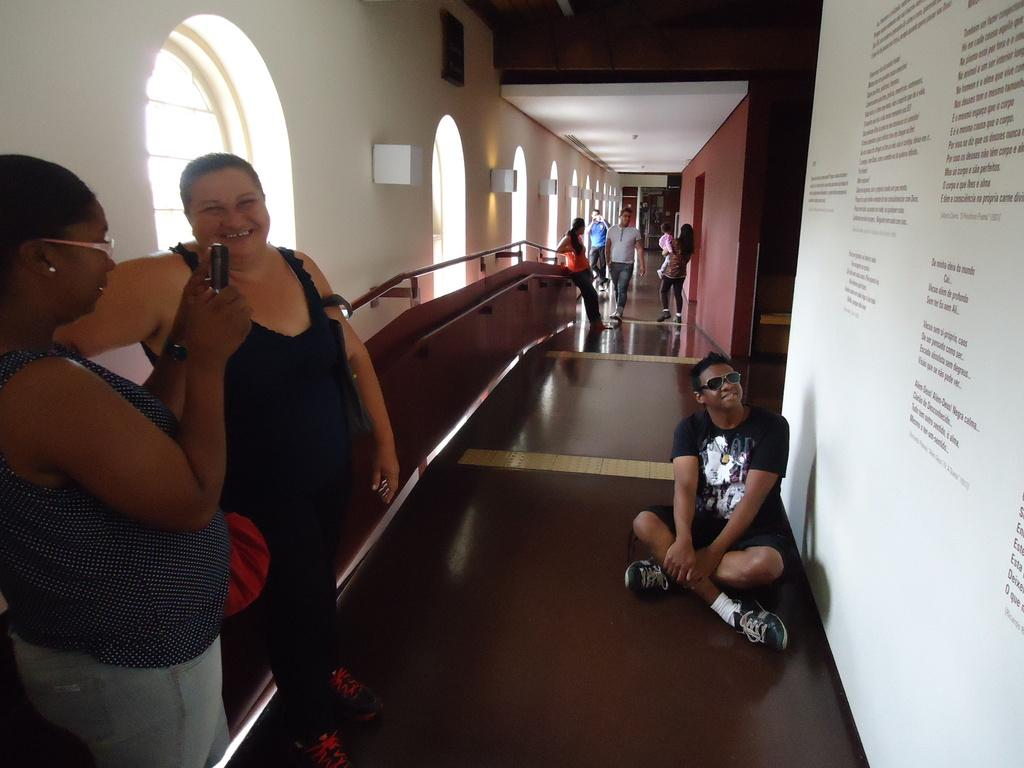What is the main object in the image? There is a whiteboard in the image. Are there any people present in the image? Yes, there are people standing in the image. What is the lady holding at the left side of the image? A lady is holding an object at the left side of the image. What can be seen in the background of the image? There is a window in the image. How does the chin of the lady holding the object increase in size in the image? There is no indication in the image that the lady's chin is increasing in size, and therefore no such change can be observed. 